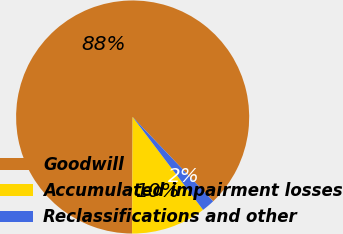Convert chart. <chart><loc_0><loc_0><loc_500><loc_500><pie_chart><fcel>Goodwill<fcel>Accumulated impairment losses<fcel>Reclassifications and other<nl><fcel>87.78%<fcel>10.41%<fcel>1.81%<nl></chart> 